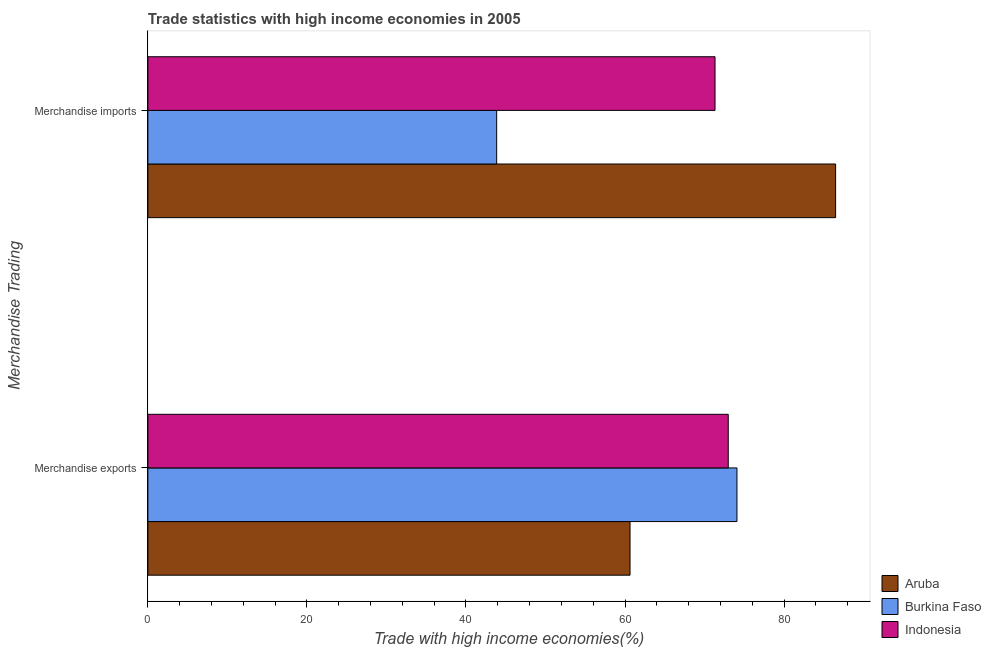Are the number of bars on each tick of the Y-axis equal?
Your answer should be compact. Yes. How many bars are there on the 2nd tick from the bottom?
Your answer should be very brief. 3. What is the merchandise imports in Burkina Faso?
Ensure brevity in your answer.  43.86. Across all countries, what is the maximum merchandise imports?
Offer a very short reply. 86.48. Across all countries, what is the minimum merchandise imports?
Your response must be concise. 43.86. In which country was the merchandise imports maximum?
Offer a very short reply. Aruba. In which country was the merchandise imports minimum?
Your answer should be compact. Burkina Faso. What is the total merchandise exports in the graph?
Provide a succinct answer. 207.69. What is the difference between the merchandise imports in Indonesia and that in Burkina Faso?
Offer a very short reply. 27.46. What is the difference between the merchandise imports in Aruba and the merchandise exports in Indonesia?
Offer a very short reply. 13.5. What is the average merchandise exports per country?
Provide a succinct answer. 69.23. What is the difference between the merchandise exports and merchandise imports in Aruba?
Make the answer very short. -25.85. In how many countries, is the merchandise exports greater than 64 %?
Give a very brief answer. 2. What is the ratio of the merchandise exports in Aruba to that in Burkina Faso?
Your answer should be very brief. 0.82. Is the merchandise imports in Aruba less than that in Burkina Faso?
Provide a succinct answer. No. What does the 3rd bar from the top in Merchandise exports represents?
Give a very brief answer. Aruba. What does the 1st bar from the bottom in Merchandise imports represents?
Give a very brief answer. Aruba. How many bars are there?
Keep it short and to the point. 6. How many countries are there in the graph?
Your answer should be very brief. 3. What is the difference between two consecutive major ticks on the X-axis?
Keep it short and to the point. 20. Are the values on the major ticks of X-axis written in scientific E-notation?
Make the answer very short. No. Does the graph contain grids?
Keep it short and to the point. No. How many legend labels are there?
Ensure brevity in your answer.  3. How are the legend labels stacked?
Offer a very short reply. Vertical. What is the title of the graph?
Keep it short and to the point. Trade statistics with high income economies in 2005. What is the label or title of the X-axis?
Offer a terse response. Trade with high income economies(%). What is the label or title of the Y-axis?
Offer a very short reply. Merchandise Trading. What is the Trade with high income economies(%) in Aruba in Merchandise exports?
Make the answer very short. 60.63. What is the Trade with high income economies(%) in Burkina Faso in Merchandise exports?
Make the answer very short. 74.08. What is the Trade with high income economies(%) in Indonesia in Merchandise exports?
Your response must be concise. 72.98. What is the Trade with high income economies(%) of Aruba in Merchandise imports?
Ensure brevity in your answer.  86.48. What is the Trade with high income economies(%) of Burkina Faso in Merchandise imports?
Provide a short and direct response. 43.86. What is the Trade with high income economies(%) in Indonesia in Merchandise imports?
Give a very brief answer. 71.32. Across all Merchandise Trading, what is the maximum Trade with high income economies(%) in Aruba?
Offer a very short reply. 86.48. Across all Merchandise Trading, what is the maximum Trade with high income economies(%) of Burkina Faso?
Keep it short and to the point. 74.08. Across all Merchandise Trading, what is the maximum Trade with high income economies(%) in Indonesia?
Your answer should be compact. 72.98. Across all Merchandise Trading, what is the minimum Trade with high income economies(%) of Aruba?
Provide a succinct answer. 60.63. Across all Merchandise Trading, what is the minimum Trade with high income economies(%) of Burkina Faso?
Offer a terse response. 43.86. Across all Merchandise Trading, what is the minimum Trade with high income economies(%) in Indonesia?
Your response must be concise. 71.32. What is the total Trade with high income economies(%) in Aruba in the graph?
Offer a terse response. 147.11. What is the total Trade with high income economies(%) of Burkina Faso in the graph?
Give a very brief answer. 117.94. What is the total Trade with high income economies(%) of Indonesia in the graph?
Make the answer very short. 144.3. What is the difference between the Trade with high income economies(%) of Aruba in Merchandise exports and that in Merchandise imports?
Make the answer very short. -25.85. What is the difference between the Trade with high income economies(%) of Burkina Faso in Merchandise exports and that in Merchandise imports?
Your answer should be compact. 30.22. What is the difference between the Trade with high income economies(%) in Indonesia in Merchandise exports and that in Merchandise imports?
Give a very brief answer. 1.66. What is the difference between the Trade with high income economies(%) of Aruba in Merchandise exports and the Trade with high income economies(%) of Burkina Faso in Merchandise imports?
Give a very brief answer. 16.77. What is the difference between the Trade with high income economies(%) in Aruba in Merchandise exports and the Trade with high income economies(%) in Indonesia in Merchandise imports?
Your response must be concise. -10.69. What is the difference between the Trade with high income economies(%) in Burkina Faso in Merchandise exports and the Trade with high income economies(%) in Indonesia in Merchandise imports?
Offer a terse response. 2.76. What is the average Trade with high income economies(%) in Aruba per Merchandise Trading?
Provide a short and direct response. 73.56. What is the average Trade with high income economies(%) of Burkina Faso per Merchandise Trading?
Your response must be concise. 58.97. What is the average Trade with high income economies(%) in Indonesia per Merchandise Trading?
Offer a terse response. 72.15. What is the difference between the Trade with high income economies(%) in Aruba and Trade with high income economies(%) in Burkina Faso in Merchandise exports?
Your answer should be very brief. -13.45. What is the difference between the Trade with high income economies(%) in Aruba and Trade with high income economies(%) in Indonesia in Merchandise exports?
Provide a succinct answer. -12.35. What is the difference between the Trade with high income economies(%) in Burkina Faso and Trade with high income economies(%) in Indonesia in Merchandise exports?
Ensure brevity in your answer.  1.1. What is the difference between the Trade with high income economies(%) of Aruba and Trade with high income economies(%) of Burkina Faso in Merchandise imports?
Give a very brief answer. 42.62. What is the difference between the Trade with high income economies(%) in Aruba and Trade with high income economies(%) in Indonesia in Merchandise imports?
Your answer should be very brief. 15.16. What is the difference between the Trade with high income economies(%) of Burkina Faso and Trade with high income economies(%) of Indonesia in Merchandise imports?
Keep it short and to the point. -27.46. What is the ratio of the Trade with high income economies(%) in Aruba in Merchandise exports to that in Merchandise imports?
Keep it short and to the point. 0.7. What is the ratio of the Trade with high income economies(%) of Burkina Faso in Merchandise exports to that in Merchandise imports?
Offer a terse response. 1.69. What is the ratio of the Trade with high income economies(%) of Indonesia in Merchandise exports to that in Merchandise imports?
Offer a terse response. 1.02. What is the difference between the highest and the second highest Trade with high income economies(%) in Aruba?
Make the answer very short. 25.85. What is the difference between the highest and the second highest Trade with high income economies(%) in Burkina Faso?
Give a very brief answer. 30.22. What is the difference between the highest and the second highest Trade with high income economies(%) of Indonesia?
Offer a very short reply. 1.66. What is the difference between the highest and the lowest Trade with high income economies(%) of Aruba?
Provide a short and direct response. 25.85. What is the difference between the highest and the lowest Trade with high income economies(%) of Burkina Faso?
Your answer should be compact. 30.22. What is the difference between the highest and the lowest Trade with high income economies(%) in Indonesia?
Give a very brief answer. 1.66. 